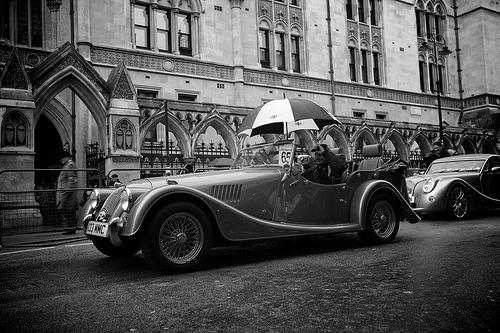Assess the image quality based on its sharpness, clarity, and overall appearance. Considering the black and white nature and the level of detail in the objects depicted, the image quality can be considered as good or moderately high. What type of car is featured prominently in the image and what is unique about its appearance? A convertible vintage sports car is prominently featured, and it has metallic chrome rims, a black and white license plate on the front, and the number 65 in the car window. Count the number of people present in the image and describe their attire. There are two people present - one man wearing a hat and coat, holding an umbrella and driving the car, and another person sitting in the car. What type of fence is located next to the sidewalk, and what material is it made of? There is a short metal fence or metal barricade next to the sidewalk. What is the architectural style of the building in the photograph as indicated by the elements described? The building is a stone structure with an arched doorway, three windows, and an arched design on the stone wall, indicating a classical or historic architectural style. What is the role of the umbrella in the image, and what makes it visually distinctive? The umbrella is being held by the man driving the car, likely to protect himself and the other person in the car from the rain or sun. It is visually distinctive due to its black and white design. What type of sentiment or atmosphere does the image convey and why? The image conveys a vintage, nostalgic atmosphere due to the black and white photograph, old-fashioned cars, the man's attire, and the classical architectural style of the building. Describe the interaction between the man and the car in the image. The man is holding a black and white umbrella, driving the old sports car, and waving to the crowd. There is another person sitting in the car as well. How many wheels are clearly visible in the image, and where are they located? Six wheels are visible - two on the side of the vintage car, one on the second old-fashioned car, and three more on different cars throughout the image. Identify the main elements in the black and white photograph and their respective positions. There are two antique cars with chrome wheels parked on the asphalt next to a stone building with arched doorway, three windows, and a black old-fashioned street lamp. A man, wearing a hat and coat, stands on the sidewalk behind a short metal fence. 